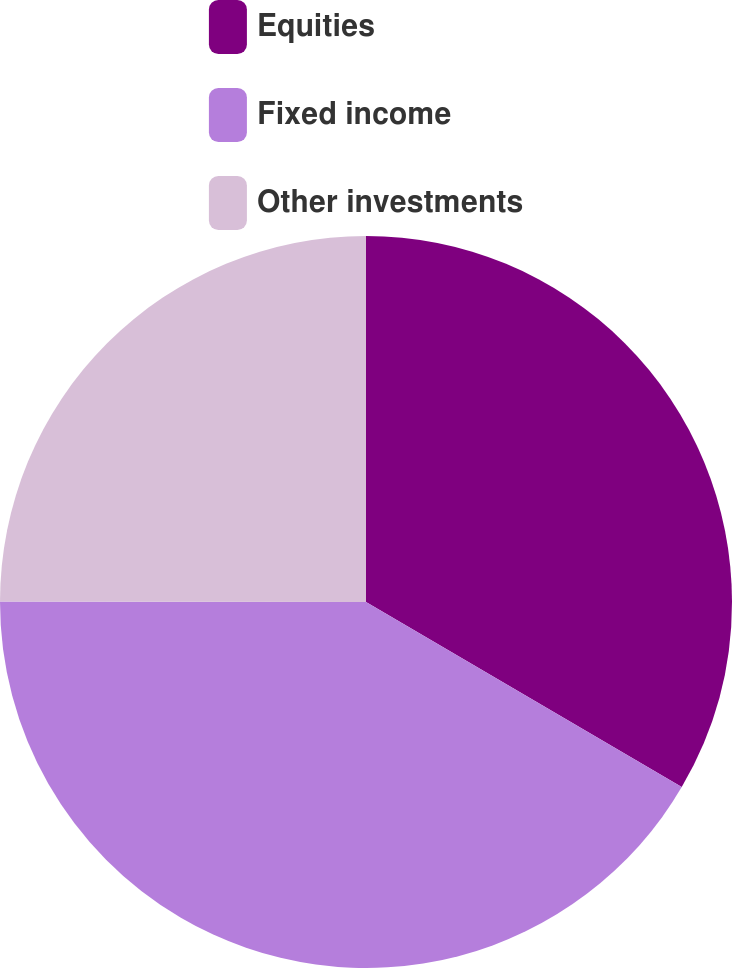<chart> <loc_0><loc_0><loc_500><loc_500><pie_chart><fcel>Equities<fcel>Fixed income<fcel>Other investments<nl><fcel>33.44%<fcel>41.58%<fcel>24.98%<nl></chart> 